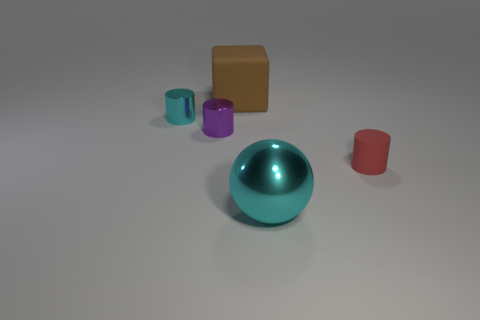Are there more small cyan things than large blue matte blocks?
Offer a terse response. Yes. How many other things are there of the same shape as the brown matte object?
Give a very brief answer. 0. There is a thing that is both to the right of the purple metal cylinder and behind the rubber cylinder; what is its material?
Ensure brevity in your answer.  Rubber. What is the size of the sphere?
Give a very brief answer. Large. There is a matte object to the right of the big thing on the right side of the brown object; what number of cylinders are to the left of it?
Your answer should be very brief. 2. The large cyan thing that is in front of the small purple metal cylinder that is on the left side of the large brown thing is what shape?
Make the answer very short. Sphere. What is the size of the red rubber object that is the same shape as the small cyan metal object?
Your answer should be compact. Small. There is a tiny cylinder right of the big cyan metal object; what color is it?
Make the answer very short. Red. What is the material of the cyan object behind the cyan metallic thing in front of the cyan metallic object that is behind the large cyan ball?
Offer a terse response. Metal. How big is the cyan thing behind the metal object in front of the purple object?
Make the answer very short. Small. 